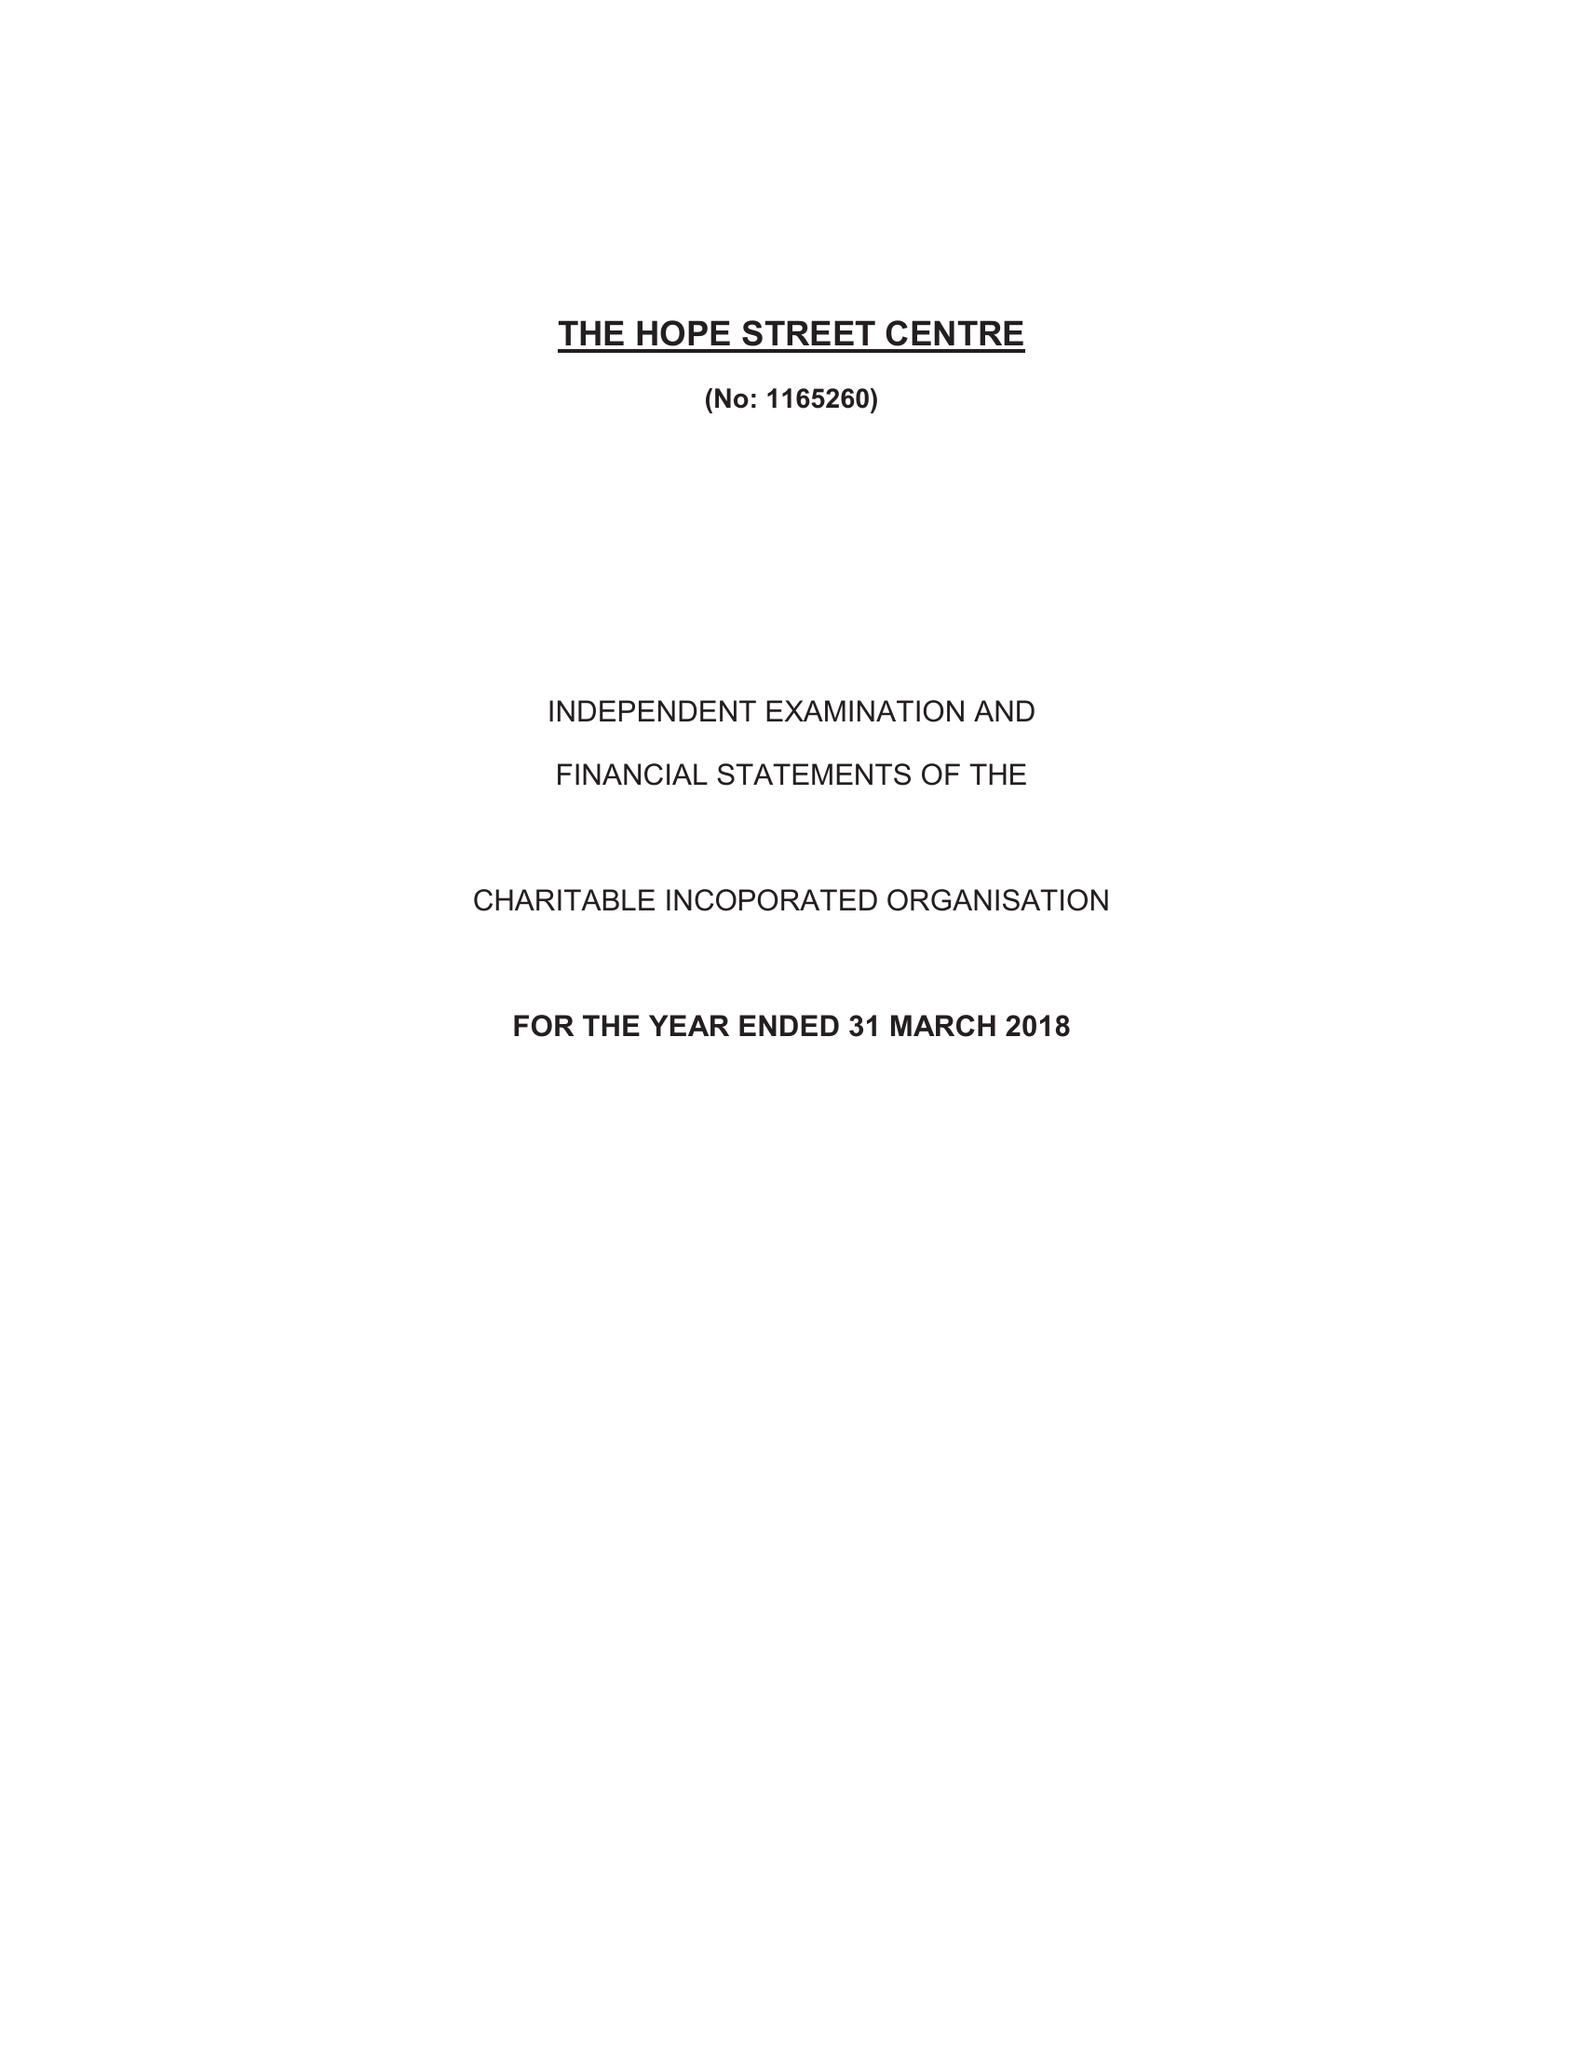What is the value for the address__postcode?
Answer the question using a single word or phrase. ME12 1AJ 